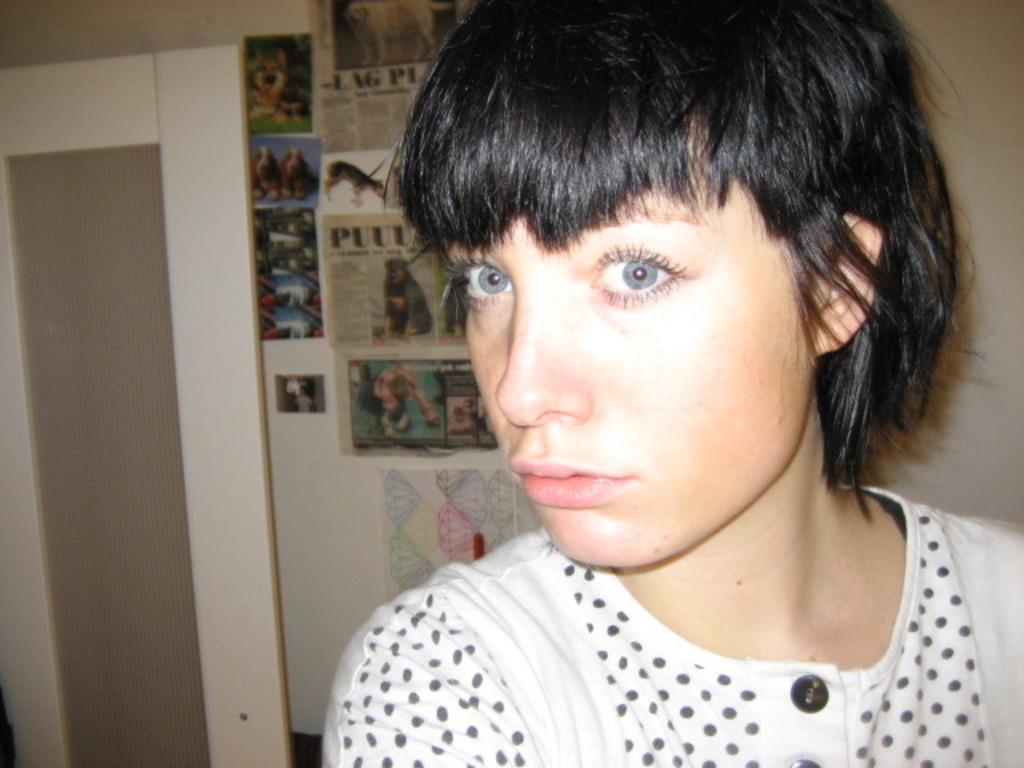Could you give a brief overview of what you see in this image? In this image, we can see a person. We can also see a door. In the background, we can see the wall with some posters. 